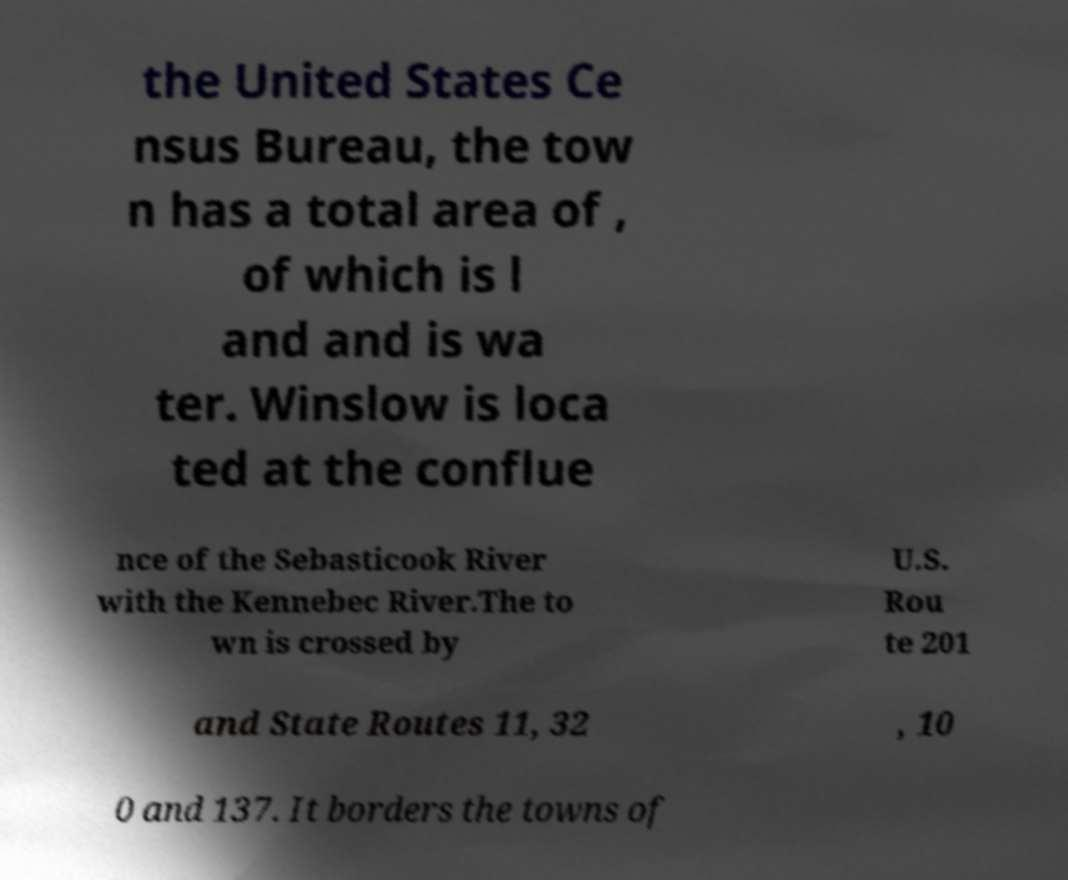Could you extract and type out the text from this image? the United States Ce nsus Bureau, the tow n has a total area of , of which is l and and is wa ter. Winslow is loca ted at the conflue nce of the Sebasticook River with the Kennebec River.The to wn is crossed by U.S. Rou te 201 and State Routes 11, 32 , 10 0 and 137. It borders the towns of 